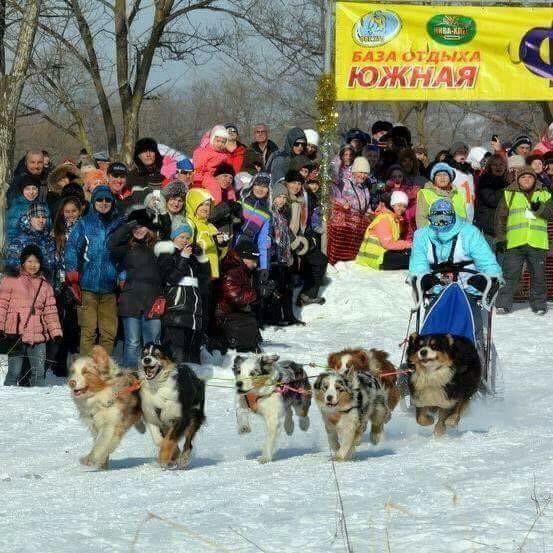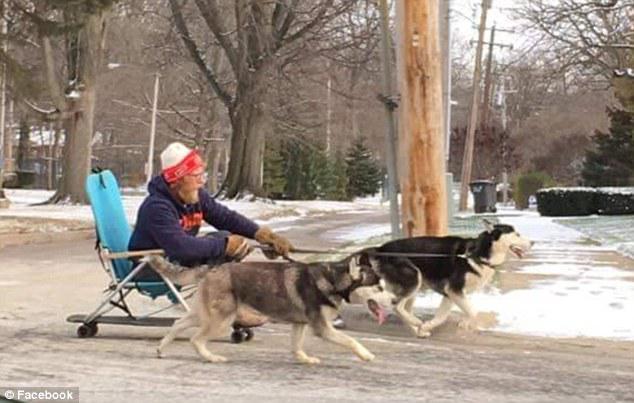The first image is the image on the left, the second image is the image on the right. Assess this claim about the two images: "One of the images shows exactly two dogs pulling the sled.". Correct or not? Answer yes or no. Yes. The first image is the image on the left, the second image is the image on the right. For the images displayed, is the sentence "A crowd of people stand packed together on the left to watch a sled dog race, in one image." factually correct? Answer yes or no. Yes. 